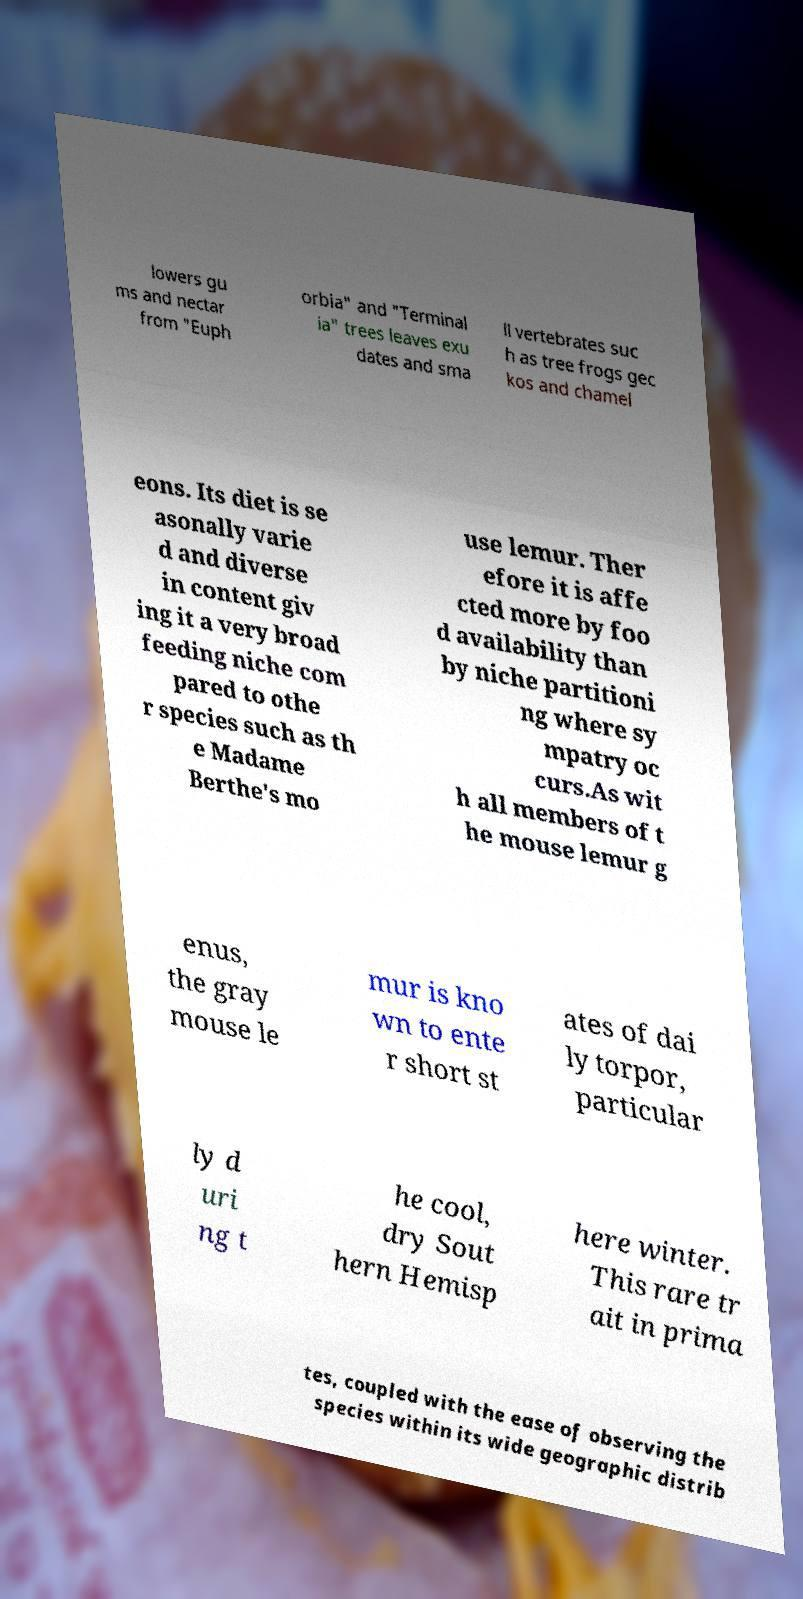Can you accurately transcribe the text from the provided image for me? lowers gu ms and nectar from "Euph orbia" and "Terminal ia" trees leaves exu dates and sma ll vertebrates suc h as tree frogs gec kos and chamel eons. Its diet is se asonally varie d and diverse in content giv ing it a very broad feeding niche com pared to othe r species such as th e Madame Berthe's mo use lemur. Ther efore it is affe cted more by foo d availability than by niche partitioni ng where sy mpatry oc curs.As wit h all members of t he mouse lemur g enus, the gray mouse le mur is kno wn to ente r short st ates of dai ly torpor, particular ly d uri ng t he cool, dry Sout hern Hemisp here winter. This rare tr ait in prima tes, coupled with the ease of observing the species within its wide geographic distrib 